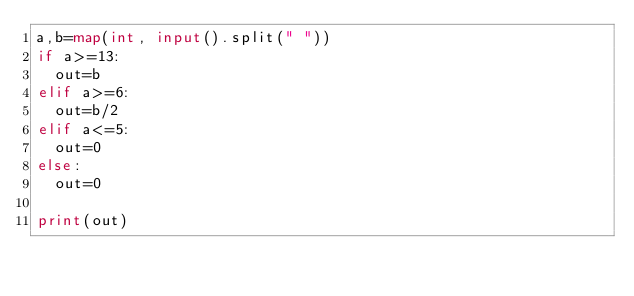Convert code to text. <code><loc_0><loc_0><loc_500><loc_500><_Python_>a,b=map(int, input().split(" "))
if a>=13:
  out=b
elif a>=6:
  out=b/2
elif a<=5:
  out=0
else:
  out=0
  
print(out)</code> 